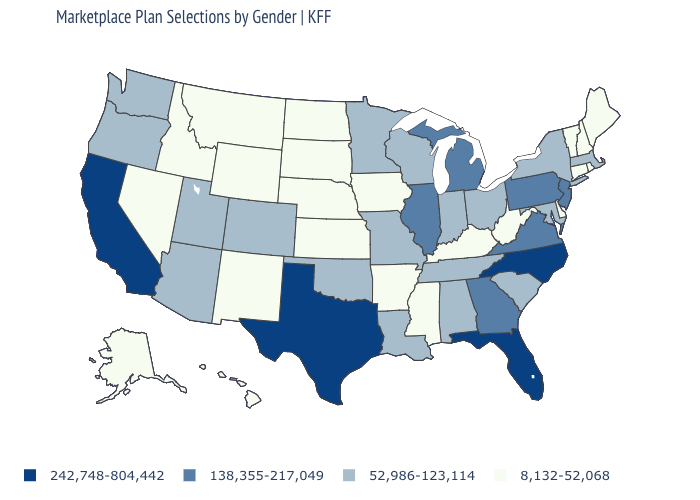Does Missouri have the same value as Idaho?
Write a very short answer. No. What is the lowest value in the USA?
Quick response, please. 8,132-52,068. What is the value of Oregon?
Be succinct. 52,986-123,114. How many symbols are there in the legend?
Keep it brief. 4. Does the map have missing data?
Concise answer only. No. Name the states that have a value in the range 242,748-804,442?
Be succinct. California, Florida, North Carolina, Texas. Name the states that have a value in the range 52,986-123,114?
Give a very brief answer. Alabama, Arizona, Colorado, Indiana, Louisiana, Maryland, Massachusetts, Minnesota, Missouri, New York, Ohio, Oklahoma, Oregon, South Carolina, Tennessee, Utah, Washington, Wisconsin. Does Maryland have the same value as Wisconsin?
Be succinct. Yes. Among the states that border Louisiana , which have the highest value?
Answer briefly. Texas. What is the value of South Dakota?
Quick response, please. 8,132-52,068. Which states have the highest value in the USA?
Be succinct. California, Florida, North Carolina, Texas. What is the highest value in states that border Virginia?
Quick response, please. 242,748-804,442. Among the states that border Wisconsin , which have the lowest value?
Quick response, please. Iowa. Does North Dakota have the same value as Oklahoma?
Be succinct. No. What is the value of Louisiana?
Concise answer only. 52,986-123,114. 